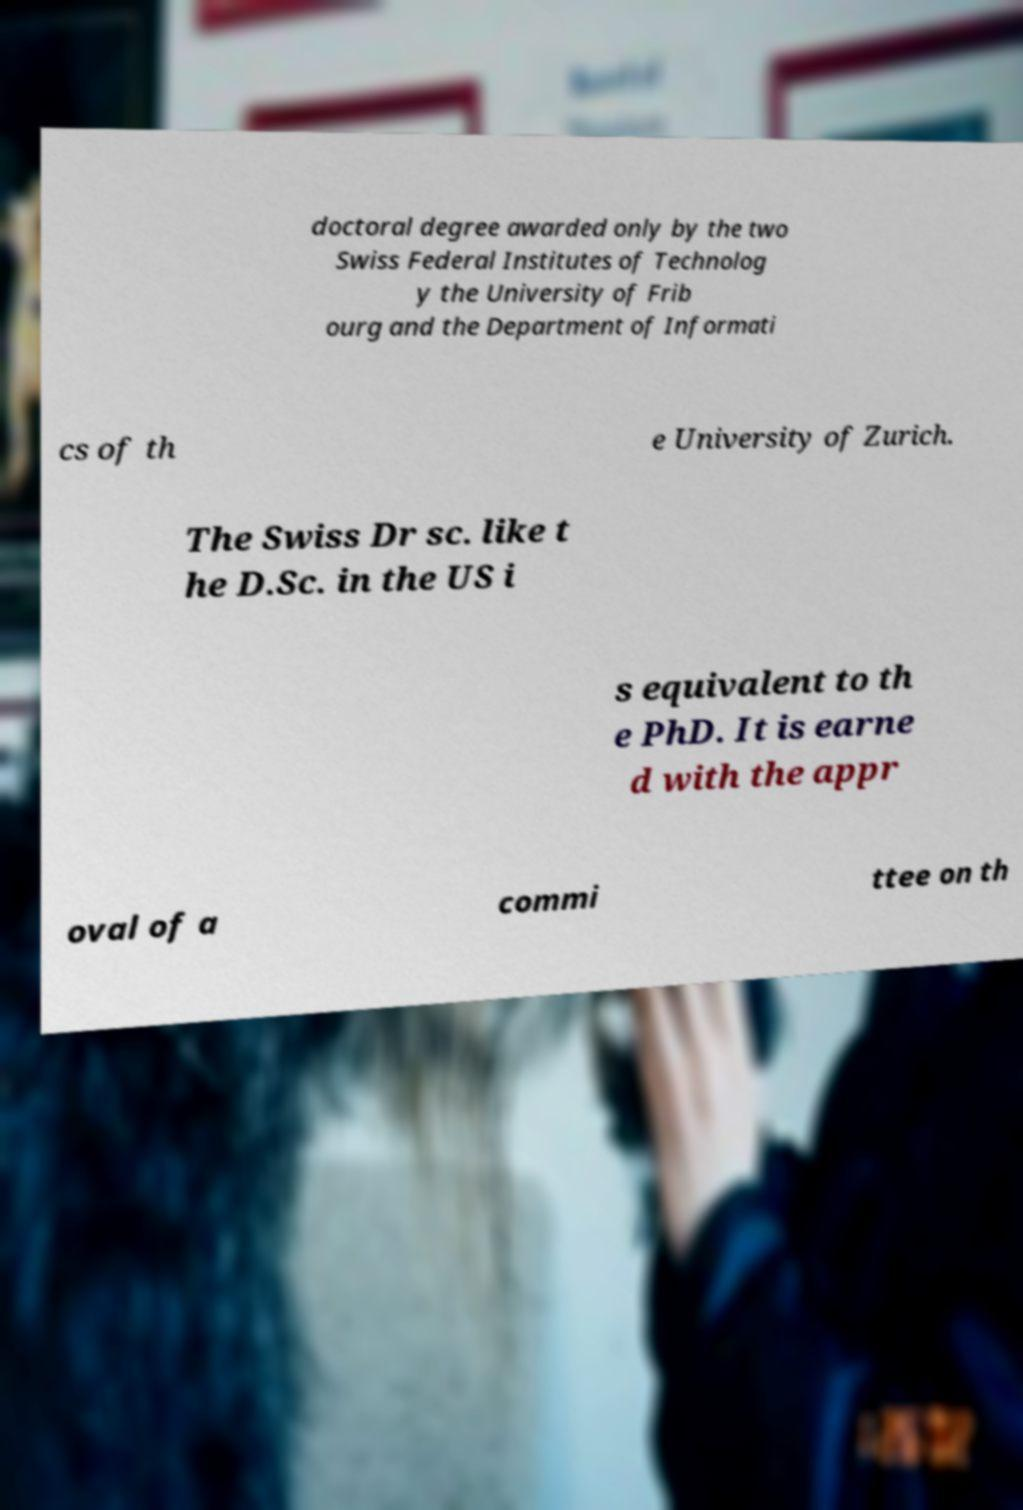Please identify and transcribe the text found in this image. doctoral degree awarded only by the two Swiss Federal Institutes of Technolog y the University of Frib ourg and the Department of Informati cs of th e University of Zurich. The Swiss Dr sc. like t he D.Sc. in the US i s equivalent to th e PhD. It is earne d with the appr oval of a commi ttee on th 